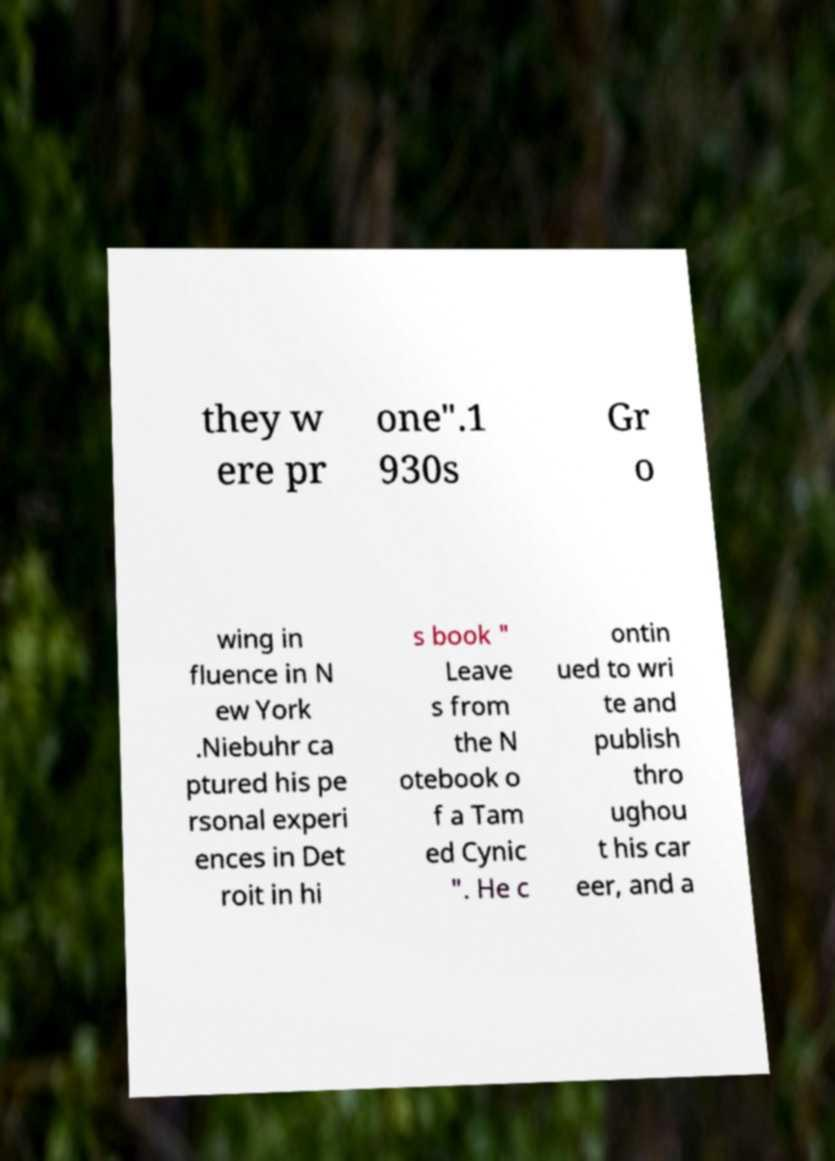What messages or text are displayed in this image? I need them in a readable, typed format. they w ere pr one".1 930s Gr o wing in fluence in N ew York .Niebuhr ca ptured his pe rsonal experi ences in Det roit in hi s book " Leave s from the N otebook o f a Tam ed Cynic ". He c ontin ued to wri te and publish thro ughou t his car eer, and a 